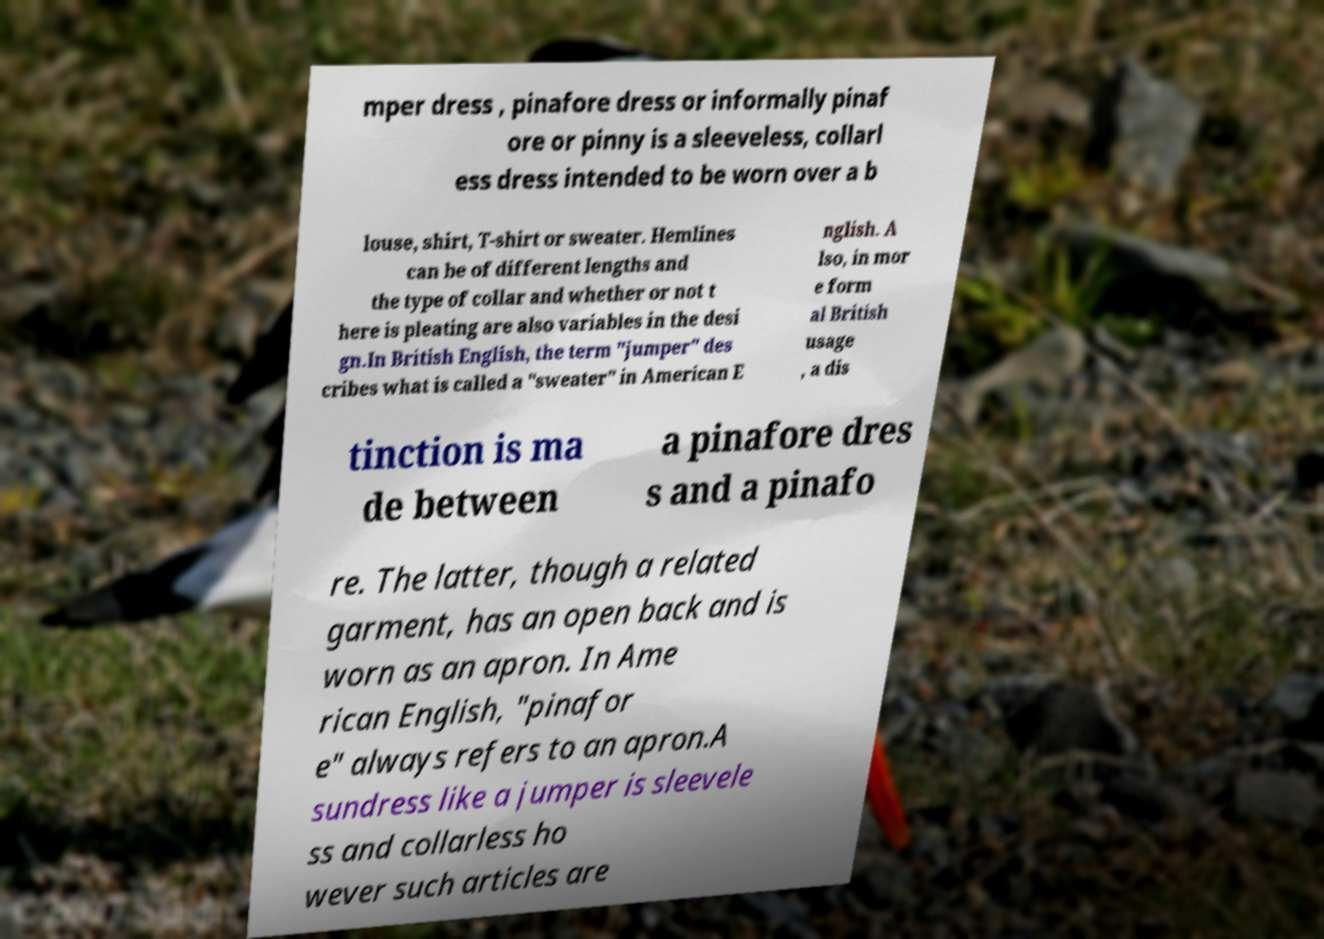I need the written content from this picture converted into text. Can you do that? mper dress , pinafore dress or informally pinaf ore or pinny is a sleeveless, collarl ess dress intended to be worn over a b louse, shirt, T-shirt or sweater. Hemlines can be of different lengths and the type of collar and whether or not t here is pleating are also variables in the desi gn.In British English, the term "jumper" des cribes what is called a "sweater" in American E nglish. A lso, in mor e form al British usage , a dis tinction is ma de between a pinafore dres s and a pinafo re. The latter, though a related garment, has an open back and is worn as an apron. In Ame rican English, "pinafor e" always refers to an apron.A sundress like a jumper is sleevele ss and collarless ho wever such articles are 